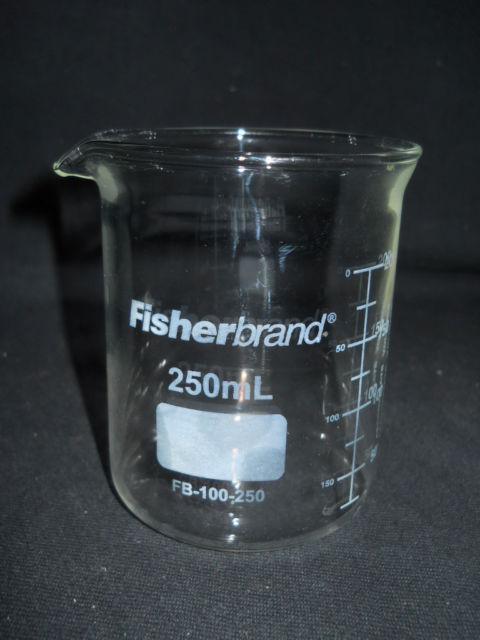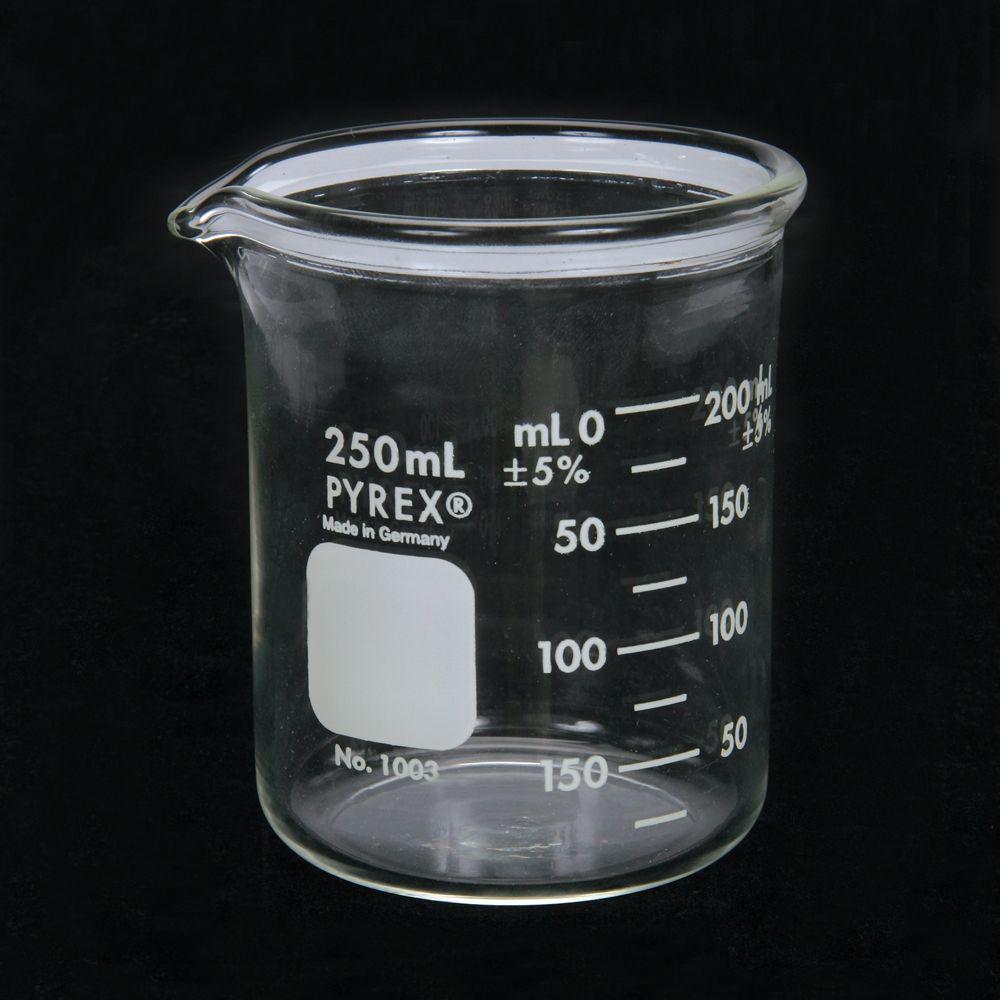The first image is the image on the left, the second image is the image on the right. Considering the images on both sides, is "There are two beakers on a dark surface." valid? Answer yes or no. Yes. The first image is the image on the left, the second image is the image on the right. Analyze the images presented: Is the assertion "There are just two beakers, and they are both on a dark background." valid? Answer yes or no. Yes. 